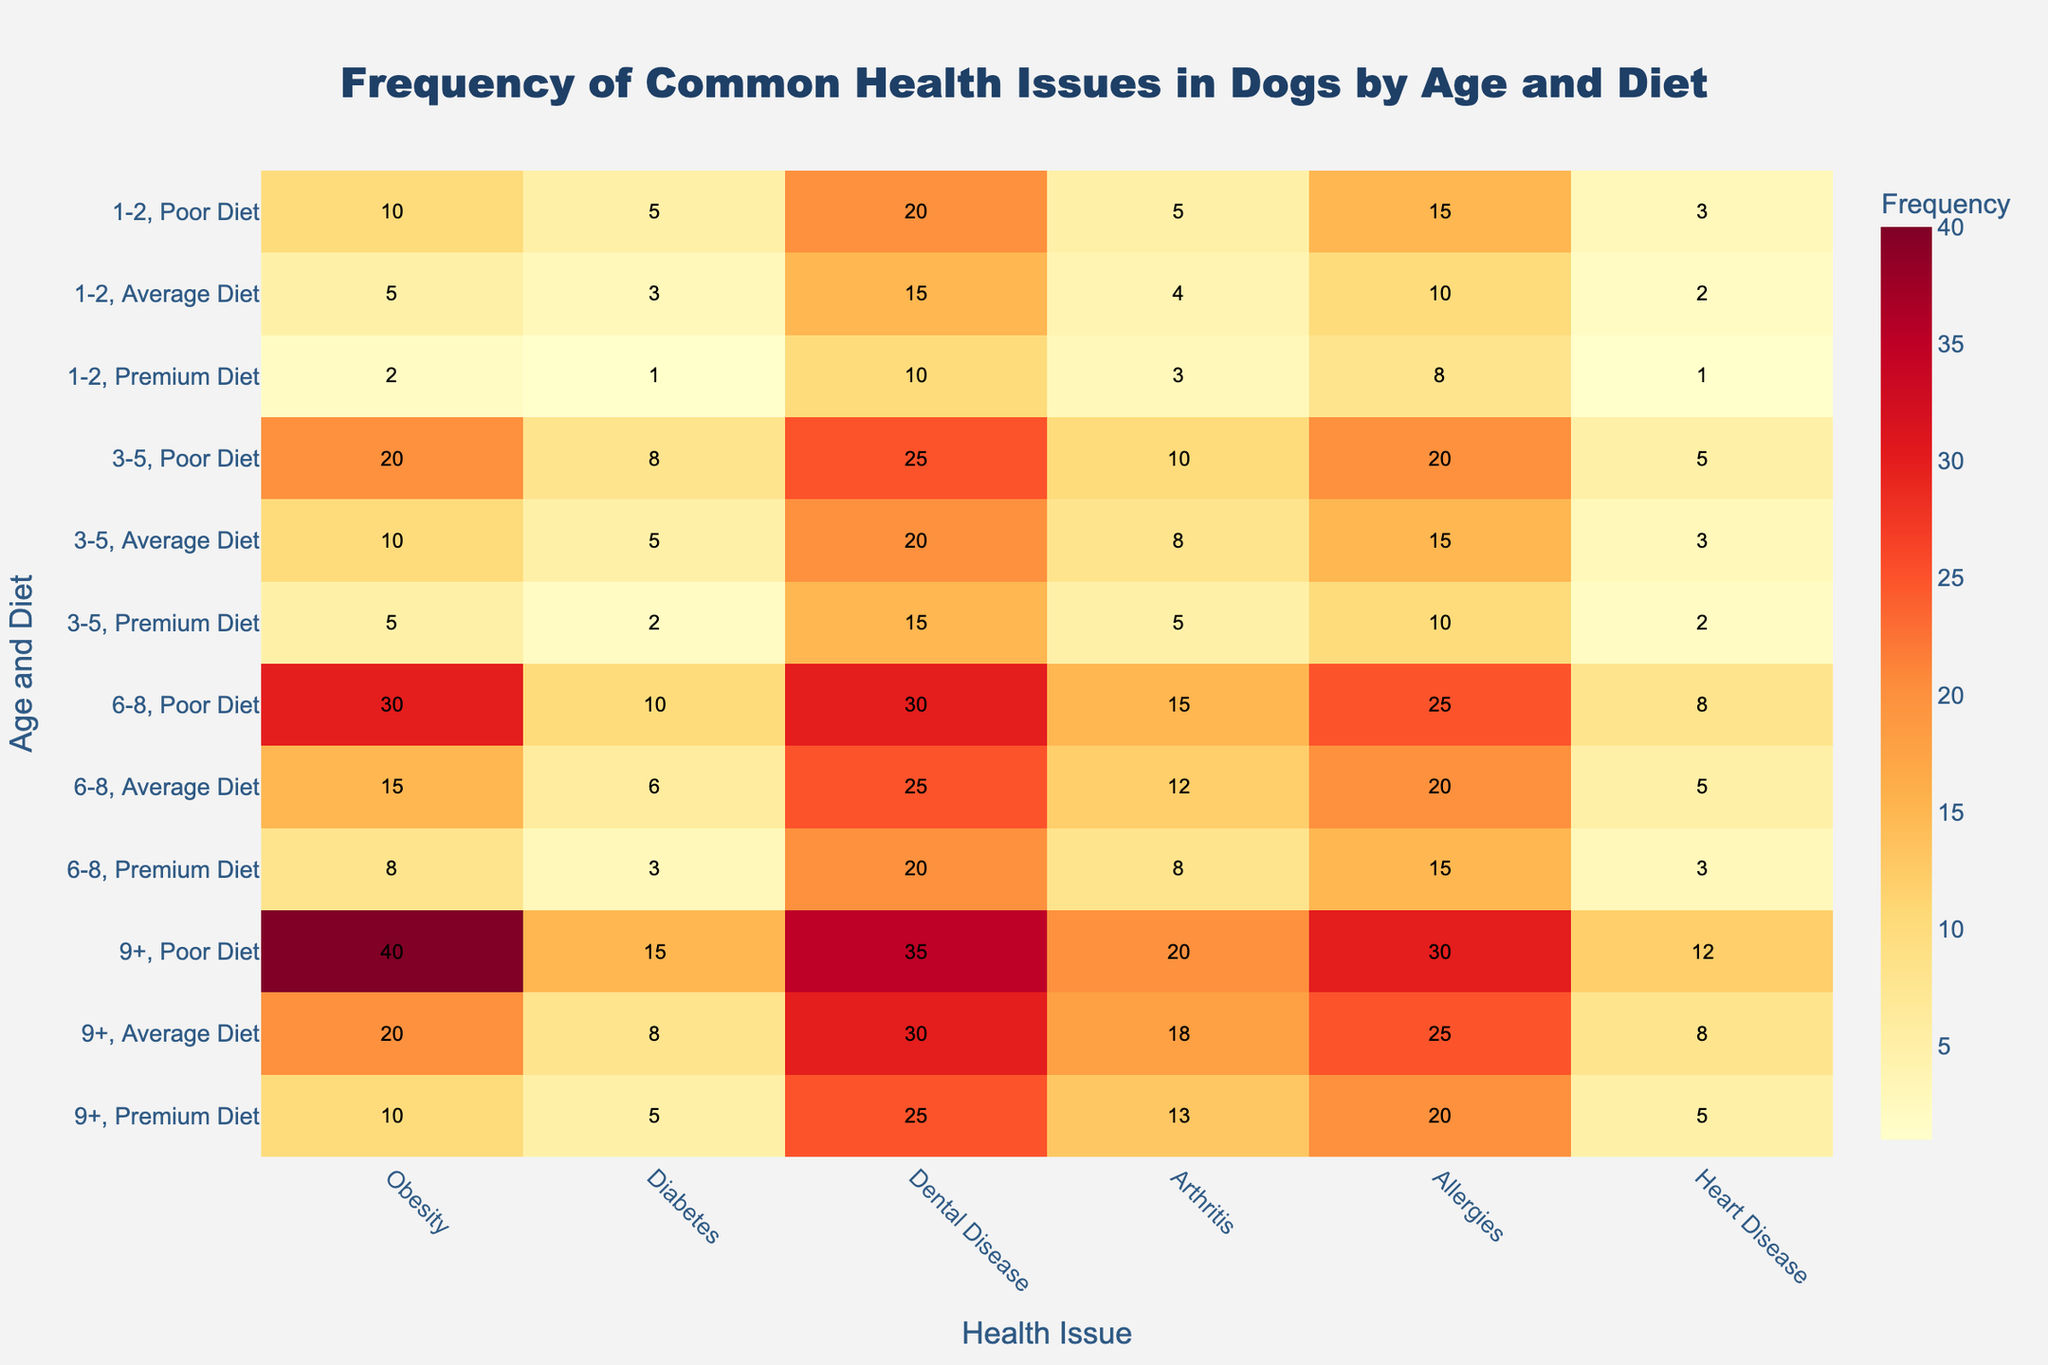What is the frequency of Obesity in dogs aged 3-5 with a Poor Diet? To find the frequency of Obesity in dogs aged 3-5 with a Poor Diet, locate the row for age 3-5 and Poor Diet, then move to the column for Obesity. The number there is 20.
Answer: 20 Between dogs aged 1-2 on an Average Diet and those aged 6-8 on a Premium Diet, which group has a higher frequency of Diabetes? Compare the frequency of Diabetes for the two groups by finding the respective values in the table. Dogs aged 1-2 on an Average Diet have a frequency of 3, while dogs aged 6-8 on a Premium Diet have a frequency of 3 as well.
Answer: Both are equal What can be inferred about the prevalence of Heart Disease as dogs age, based on the data? To infer the prevalence, look at the frequency of Heart Disease across different age groups, regardless of diet. As age increases, from 1-2 to 9+, the frequency of Heart Disease generally increases in each diet category.
Answer: Heart Disease increases with age Which diet type shows the lowest frequency of Dental Disease in dogs aged 9+? Analyze the Dental Disease frequencies for the 9+ age group across different diets (Poor, Average, Premium). The values are 35 for Poor Diet, 30 for Average Diet, and 25 for Premium Diet.
Answer: Premium Diet Is the frequency of Arthritis higher in dogs aged 6-8 on a Average Diet or dogs aged 1-2 on a Poor Diet? Compare the frequency of Arthritis for the two specific groups by checking their respective values. Dogs aged 6-8 on an Average Diet have a frequency of 12, whereas dogs aged 1-2 on a Poor Diet have a frequency of 5.
Answer: 6-8 on Average Diet What is the overall trend in the data for the frequency of Allergies as dogs age? Observe the Allergy frequencies across various age groups and diets. Generally, the frequency of Allergies increases as dogs get older, based on the Moderate and Poor diets showing increasing values across age groups.
Answer: Increases with age Among all diet types, which diet shows the highest frequency of Diabetes in dogs aged 9+? Check the Diabetes frequencies for dogs aged 9+ across all diets. The frequencies are 15 for Poor Diet, 8 for Average Diet, and 5 for Premium Diet. The Poor Diet category has the highest frequency.
Answer: Poor Diet For dogs aged 3-5, how does the frequency of Dental Disease compare between a Premium Diet and a Poor Diet? Look at the Dental Disease frequencies for dogs aged 3-5 on Premium and Poor Diets. The values are 15 for Premium Diet and 25 for Poor Diet.
Answer: Premium Diet is lower Which health issue shows the smallest difference in frequency between the Poor Diet and Premium Diet for dogs aged 6-8? Calculate the difference in frequency for each health issue between the Poor Diet and Premium Diet for dogs aged 6-8. The smallest difference is in Diabetes, which has a difference of (10-3)=7.
Answer: Diabetes 